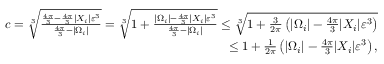Convert formula to latex. <formula><loc_0><loc_0><loc_500><loc_500>\begin{array} { r } { c = \sqrt { [ } 3 ] { \frac { \frac { 4 \pi } { 3 } - \frac { 4 \pi } { 3 } | X _ { i } | \varepsilon ^ { 3 } } { \frac { 4 \pi } { 3 } - | \Omega _ { i } | } } = \sqrt { [ } 3 ] { 1 + \frac { | \Omega _ { i } | - \frac { 4 \pi } { 3 } | X _ { i } | \varepsilon ^ { 3 } } { \frac { 4 \pi } { 3 } - | \Omega _ { i } | } } \leq \sqrt { [ } 3 ] { 1 + \frac { 3 } { 2 \pi } \left ( | \Omega _ { i } | - \frac { 4 \pi } { 3 } | X _ { i } | \varepsilon ^ { 3 } \right ) } } \\ { \leq 1 + \frac { 1 } { 2 \pi } \left ( | \Omega _ { i } | - \frac { 4 \pi } { 3 } | X _ { i } | \varepsilon ^ { 3 } \right ) , } \end{array}</formula> 